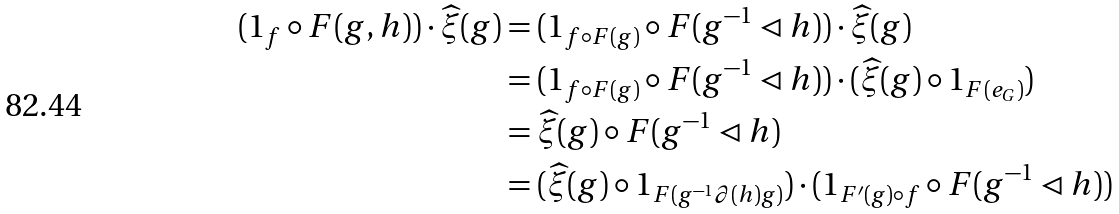<formula> <loc_0><loc_0><loc_500><loc_500>( 1 _ { f } \circ F ( g , h ) ) \cdot \widehat { \xi } ( g ) & = ( 1 _ { f \circ F ( g ) } \circ F ( g ^ { - 1 } \lhd h ) ) \cdot \widehat { \xi } ( g ) \\ & = ( 1 _ { f \circ F ( g ) } \circ F ( g ^ { - 1 } \lhd h ) ) \cdot ( \widehat { \xi } ( g ) \circ 1 _ { F ( e _ { G } ) } ) \\ & = \widehat { \xi } ( g ) \circ F ( g ^ { - 1 } \lhd h ) \\ & = ( \widehat { \xi } ( g ) \circ 1 _ { F ( g ^ { - 1 } \partial ( h ) g ) } ) \cdot ( 1 _ { F ^ { \prime } ( g ) \circ f } \circ F ( g ^ { - 1 } \lhd h ) )</formula> 